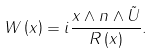Convert formula to latex. <formula><loc_0><loc_0><loc_500><loc_500>W \left ( x \right ) = i \frac { x \wedge n \wedge \tilde { U } } { R \left ( x \right ) } .</formula> 